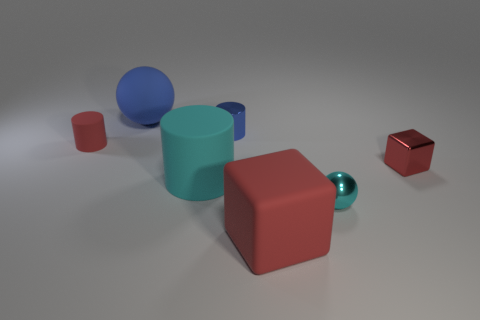What is the large ball made of?
Ensure brevity in your answer.  Rubber. What number of things are the same size as the cyan cylinder?
Your answer should be very brief. 2. Are there the same number of blue spheres that are on the right side of the big rubber block and shiny things that are in front of the cyan metal thing?
Keep it short and to the point. Yes. Is the big blue ball made of the same material as the large cylinder?
Ensure brevity in your answer.  Yes. There is a tiny cylinder that is left of the big blue rubber object; is there a red block that is behind it?
Your response must be concise. No. Are there any other small red shiny things that have the same shape as the red shiny thing?
Your response must be concise. No. Is the color of the large sphere the same as the small rubber object?
Give a very brief answer. No. What is the material of the small red object to the right of the small cylinder that is behind the small red rubber thing?
Offer a very short reply. Metal. How big is the metal cylinder?
Offer a terse response. Small. There is a red block that is made of the same material as the red cylinder; what size is it?
Keep it short and to the point. Large. 